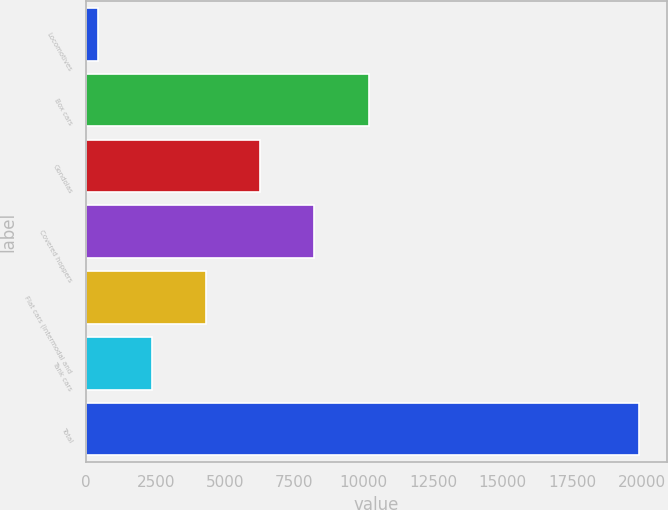<chart> <loc_0><loc_0><loc_500><loc_500><bar_chart><fcel>Locomotives<fcel>Box cars<fcel>Gondolas<fcel>Covered hoppers<fcel>Flat cars (intermodal and<fcel>Tank cars<fcel>Total<nl><fcel>416<fcel>10168<fcel>6267.2<fcel>8217.6<fcel>4316.8<fcel>2366.4<fcel>19920<nl></chart> 